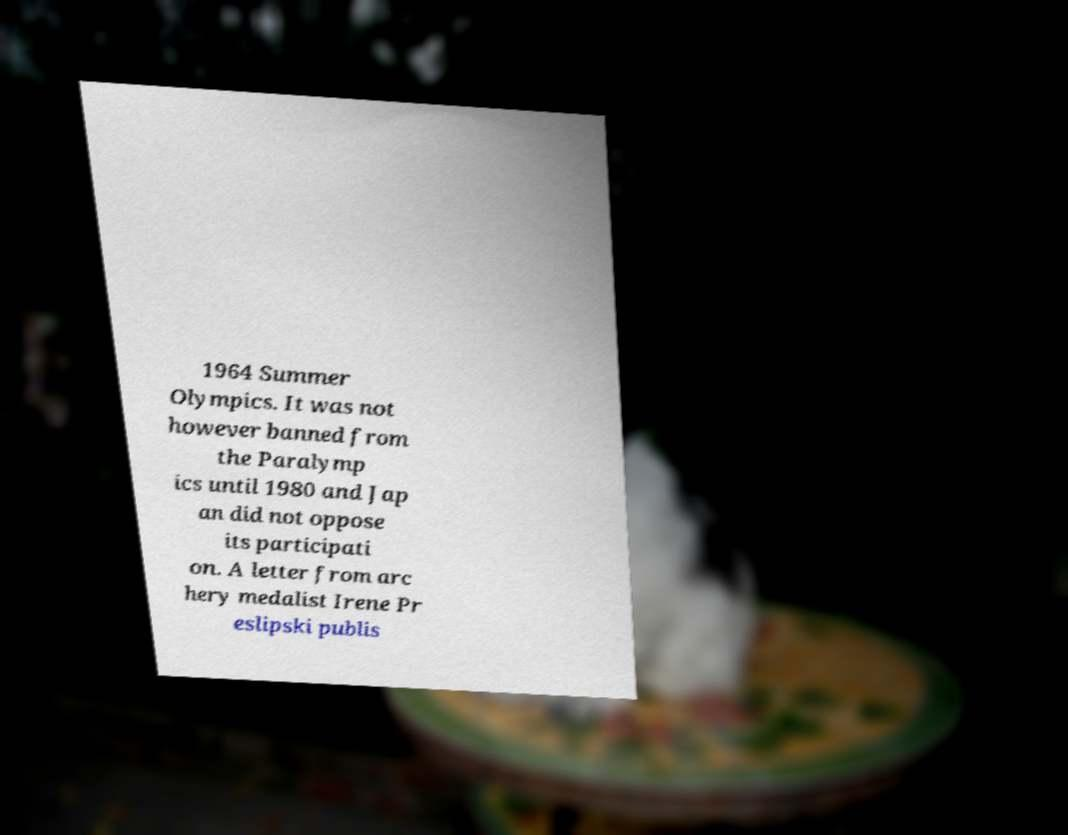Can you read and provide the text displayed in the image?This photo seems to have some interesting text. Can you extract and type it out for me? 1964 Summer Olympics. It was not however banned from the Paralymp ics until 1980 and Jap an did not oppose its participati on. A letter from arc hery medalist Irene Pr eslipski publis 